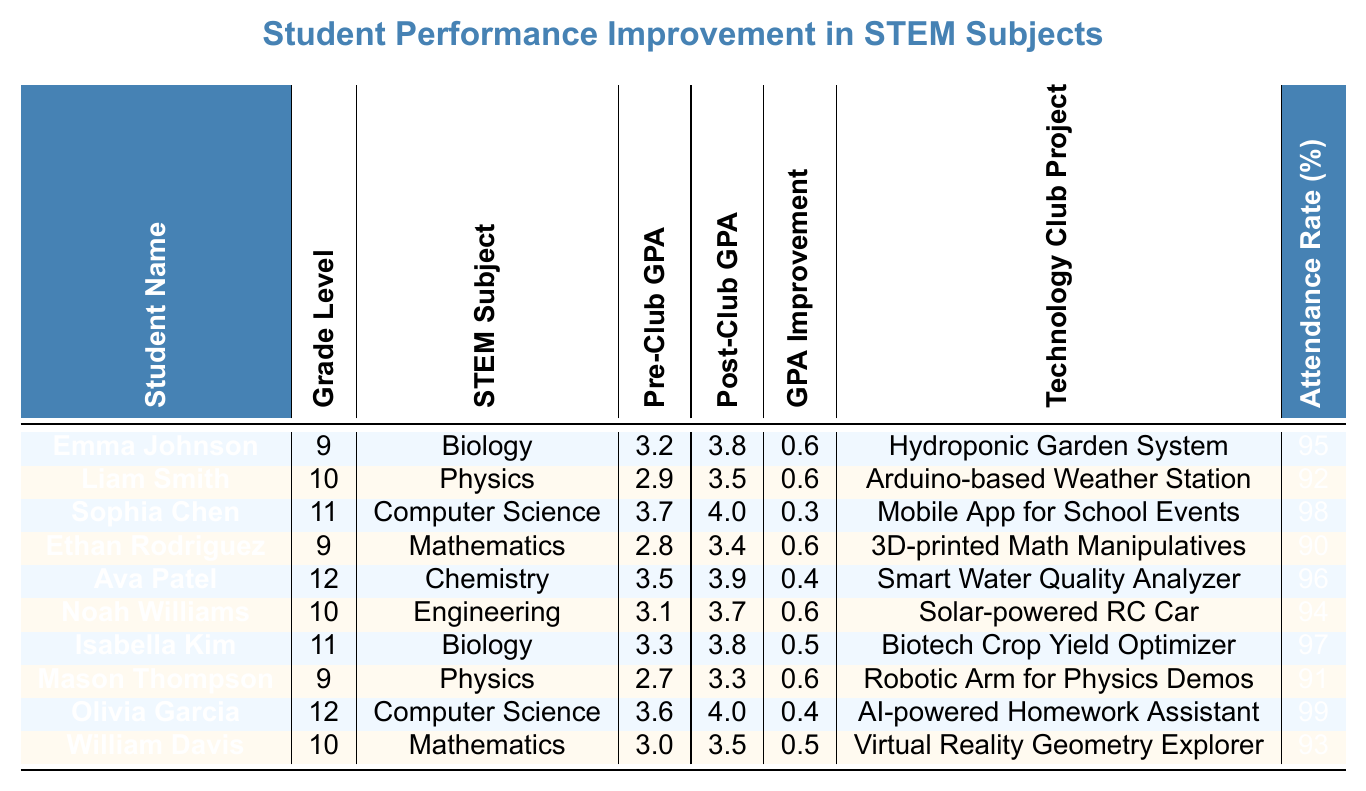What is Emma Johnson's Post-Club GPA in Biology? Looking at Emma Johnson's row in the table, her Post-Club GPA is listed as 3.8 in the Biology subject.
Answer: 3.8 Which student had the highest Attendance Rate? In the table, Olivia Garcia has the Attendance Rate of 99%, which is the highest among all students listed.
Answer: 99% What is the GPA Improvement for Liam Smith in Physics? According to the table, Liam Smith's Pre-Club GPA was 2.9 and his Post-Club GPA improved to 3.5. The improvement is calculated as 3.5 - 2.9 = 0.6.
Answer: 0.6 Did any student have a GPA Improvement of 0.3? The table shows that Sophia Chen had a GPA Improvement of 0.3 in Computer Science. Therefore, the answer is yes.
Answer: Yes What is the average GPA Improvement of the students in the table? Summing all GPA Improvements: (0.6 + 0.6 + 0.3 + 0.6 + 0.4 + 0.6 + 0.5 + 0.6 + 0.4 + 0.5) = 5.7. There are 10 students, so the average GPA Improvement is 5.7 / 10 = 0.57.
Answer: 0.57 Which student worked on the "AI-powered Homework Assistant" project? The table indicates that Olivia Garcia worked on the "AI-powered Homework Assistant" project, as her name is listed next to it.
Answer: Olivia Garcia How many students improved their GPA by 0.6 or more? By reviewing the table, the following students had GPA Improvements of 0.6 or more: Emma Johnson, Liam Smith, Ethan Rodriguez, Noah Williams, Mason Thompson. This gives a total of 5 students.
Answer: 5 What STEM subjects did students in Grade 12 focus on? The table shows that Grade 12 students, Ava Patel and Olivia Garcia, focused on Chemistry and Computer Science respectively.
Answer: Chemistry, Computer Science Which student had the lowest Pre-Club GPA and what was it? In the table, Mason Thompson has the lowest Pre-Club GPA of 2.7 in Physics.
Answer: 2.7 What is the difference between the Pre-Club GPA of Sophia Chen and the Post-Club GPA of Ethan Rodriguez? Sophia Chen's Pre-Club GPA is 3.7 and Ethan Rodriguez's Post-Club GPA is 3.4. The difference is calculated as 3.7 - 3.4 = 0.3.
Answer: 0.3 Which projects had an Attendance Rate higher than 95%? Reviewing the Attendance Rates, Olivia Garcia (99%) and Sophia Chen (98%) had rates higher than 95%. Their projects are respectively "AI-powered Homework Assistant" and "Mobile App for School Events".
Answer: Yes, Olivia Garcia and Sophia Chen 